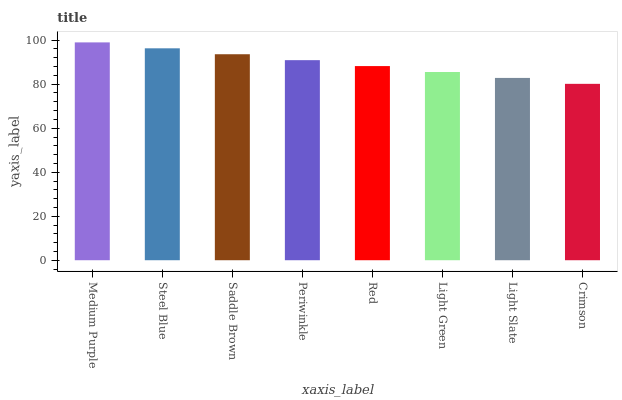Is Steel Blue the minimum?
Answer yes or no. No. Is Steel Blue the maximum?
Answer yes or no. No. Is Medium Purple greater than Steel Blue?
Answer yes or no. Yes. Is Steel Blue less than Medium Purple?
Answer yes or no. Yes. Is Steel Blue greater than Medium Purple?
Answer yes or no. No. Is Medium Purple less than Steel Blue?
Answer yes or no. No. Is Periwinkle the high median?
Answer yes or no. Yes. Is Red the low median?
Answer yes or no. Yes. Is Steel Blue the high median?
Answer yes or no. No. Is Medium Purple the low median?
Answer yes or no. No. 